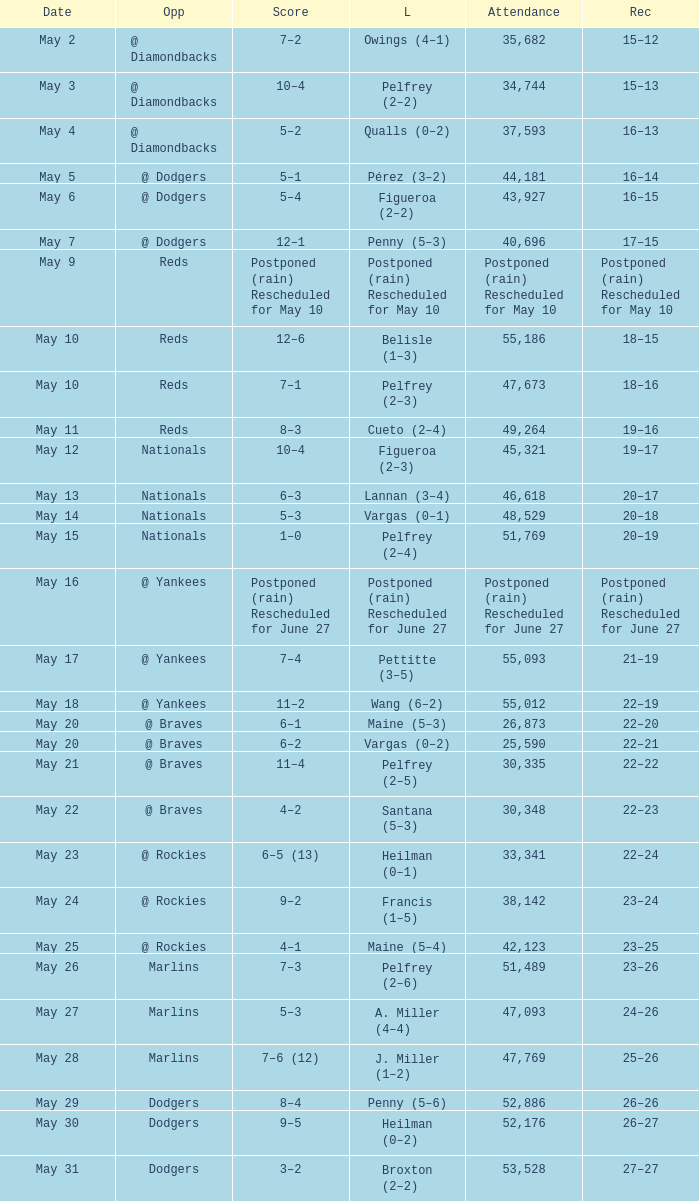Score of postponed (rain) rescheduled for June 27 had what loss? Postponed (rain) Rescheduled for June 27. 